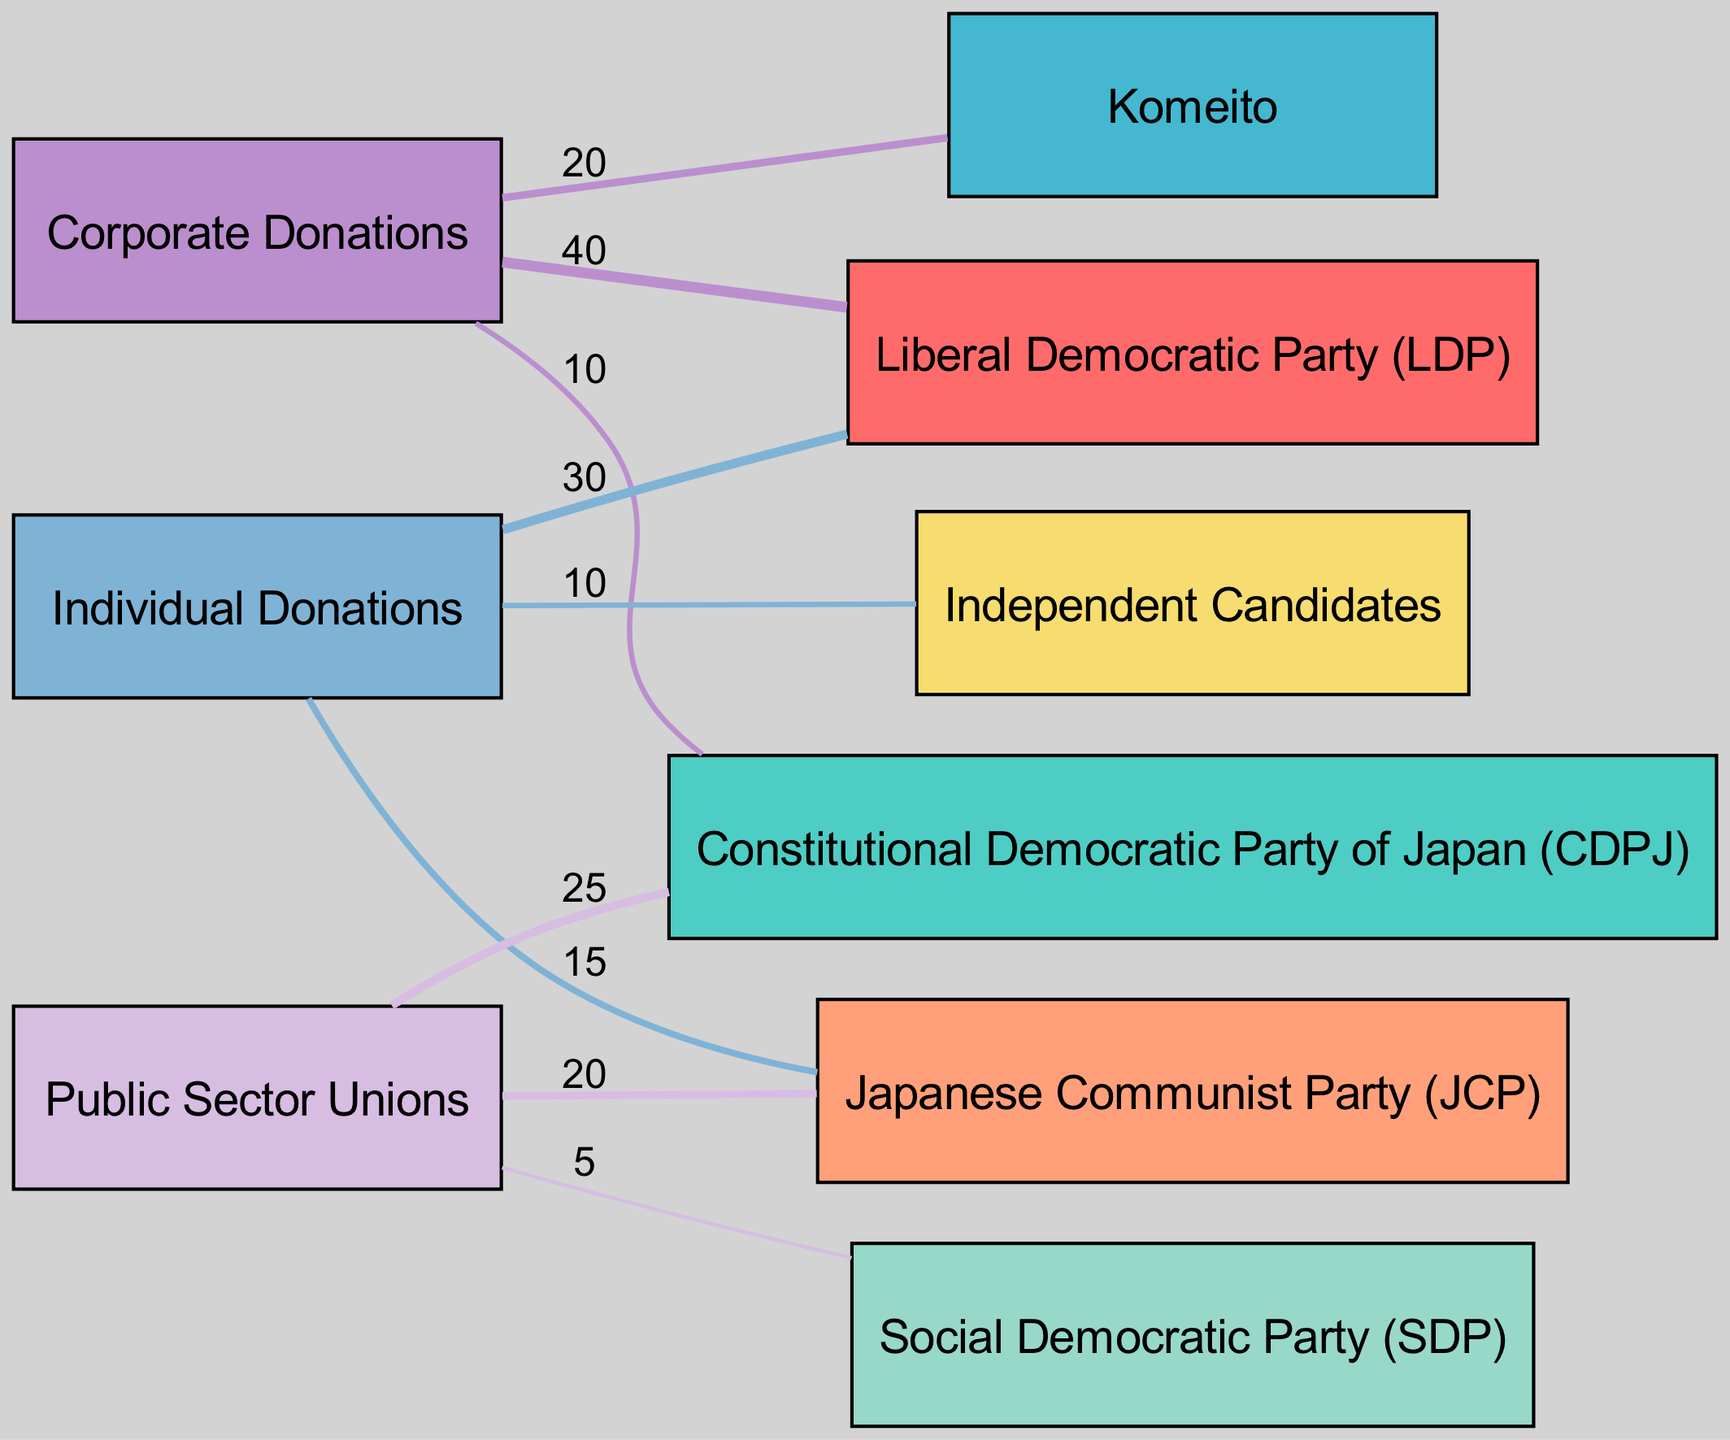What is the total amount of Corporate Donations to the Liberal Democratic Party (LDP)? The diagram shows a link from Corporate Donations to the Liberal Democratic Party (LDP) with a value of 40. Since this is the direct information requested, the answer is 40.
Answer: 40 Which party received the most from Individual Donations? By examining the Individual Donations node, we see links going to the Liberal Democratic Party (LDP) with a value of 30 and to the Japanese Communist Party (JCP) with a value of 15, and Independent Candidates with a value of 10. The highest is 30 going to the LDP.
Answer: Liberal Democratic Party (LDP) How many parties received funding from Corporate Donations? From the links, we see that Corporate Donations flow to three parties: the Liberal Democratic Party (LDP), Komeito, and Constitutional Democratic Party of Japan (CDPJ). Thus, there are three parties.
Answer: 3 What is the total value donated from Public Sector Unions? The total value from Public Sector Unions can be calculated by summing the individual contributions: 25 (to CDPJ) + 20 (to JCP) + 5 (to SDP), which equals 50.
Answer: 50 Which type of donation provided the least total funding to Social Democratic Party (SDP)? Analyzing the SDP node, the Public Sector Unions contributed a value of 5, and there are no links from Corporate or Individual Donations. Hence, the only funding is from Public Sector Unions, making it the least.
Answer: Public Sector Unions How does the flow of Corporate Donations compare to Individual Donations for LDP? The flow to LDP from Corporate Donations is 40 and from Individual Donations is 30. Thus, Corporate Donations are greater by 10.
Answer: Higher by 10 Which party received the most total funding overall? By aggregating values, LDP received 70 (40 + 30), CDPJ received 35 (10 + 25), Komeito got 20, JCP received 35 (15 + 20), SDP got 5, and Independent Candidates received 10. LDP has the highest total funding.
Answer: Liberal Democratic Party (LDP) What is the total unique number of nodes in the diagram? The nodes listed are: LDP, CDPJ, Komeito, JCP, SDP, Independent Candidates, Corporate Donations, Individual Donations, and Public Sector Unions, totaling 9 unique nodes.
Answer: 9 How much did the Japanese Communist Party (JCP) receive in total? Summing the contributions to JCP: 15 (from Individual Donations) and 20 (from Public Sector Unions) gives us a total of 35.
Answer: 35 